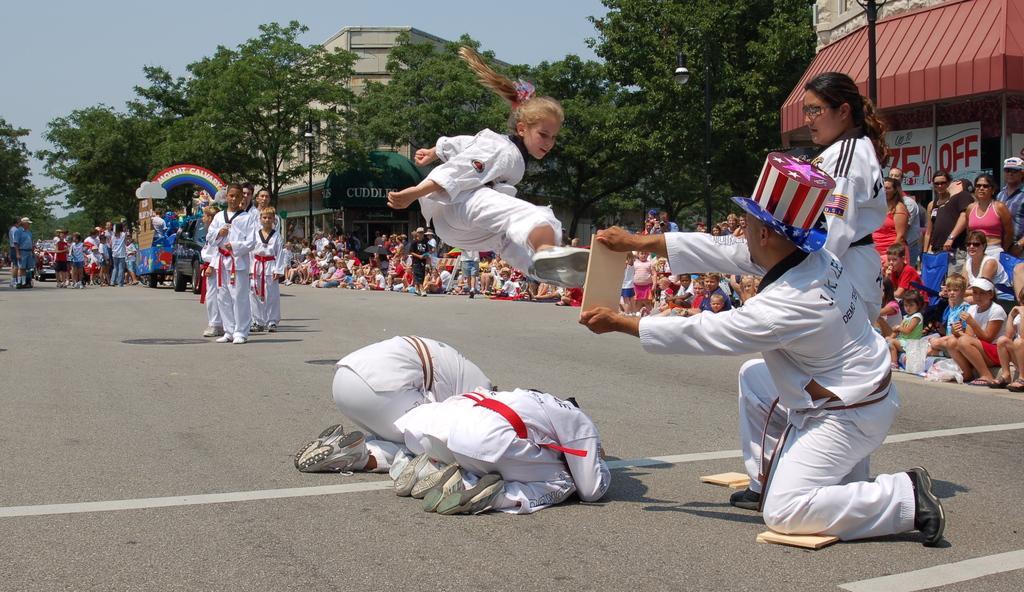How would you summarize this image in a sentence or two? In this picture we can see a group of people, vehicles on the road, trees, buildings, posters, some objects and in the background we can see the sky. 